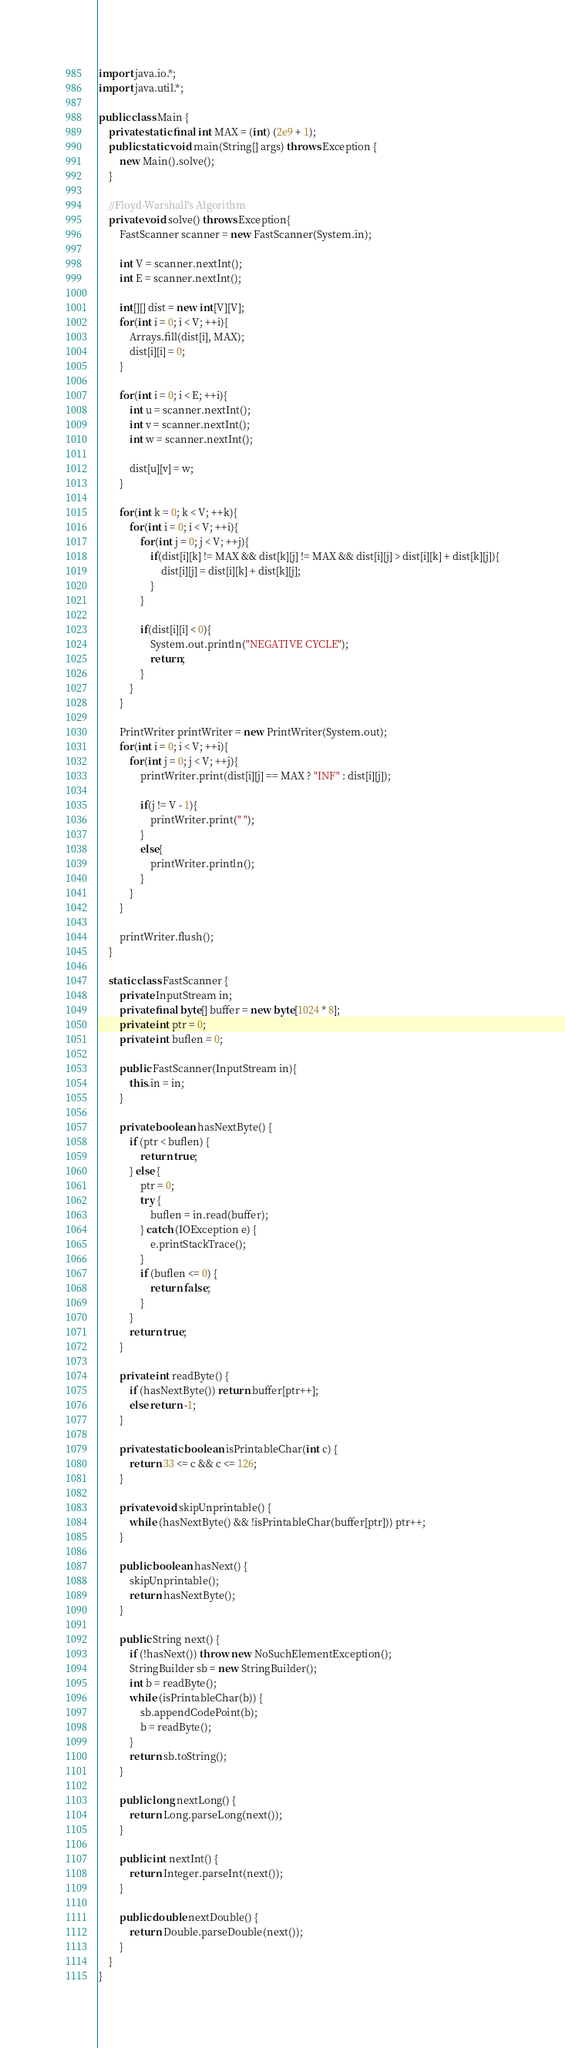<code> <loc_0><loc_0><loc_500><loc_500><_Java_>import java.io.*;
import java.util.*;

public class Main {
    private static final int MAX = (int) (2e9 + 1);
    public static void main(String[] args) throws Exception {
        new Main().solve();
    }

    //Floyd-Warshall's Algorithm
    private void solve() throws Exception{
        FastScanner scanner = new FastScanner(System.in);

        int V = scanner.nextInt();
        int E = scanner.nextInt();

        int[][] dist = new int[V][V];
        for(int i = 0; i < V; ++i){
            Arrays.fill(dist[i], MAX);
            dist[i][i] = 0;
        }

        for(int i = 0; i < E; ++i){
            int u = scanner.nextInt();
            int v = scanner.nextInt();
            int w = scanner.nextInt();

            dist[u][v] = w;
        }

        for(int k = 0; k < V; ++k){
            for(int i = 0; i < V; ++i){
                for(int j = 0; j < V; ++j){
                    if(dist[i][k] != MAX && dist[k][j] != MAX && dist[i][j] > dist[i][k] + dist[k][j]){
                        dist[i][j] = dist[i][k] + dist[k][j];
                    }
                }

                if(dist[i][i] < 0){
                    System.out.println("NEGATIVE CYCLE");
                    return;
                }
            }
        }

        PrintWriter printWriter = new PrintWriter(System.out);
        for(int i = 0; i < V; ++i){
            for(int j = 0; j < V; ++j){
                printWriter.print(dist[i][j] == MAX ? "INF" : dist[i][j]);

                if(j != V - 1){
                    printWriter.print(" ");
                }
                else{
                    printWriter.println();
                }
            }
        }

        printWriter.flush();
    }

    static class FastScanner {
        private InputStream in;
        private final byte[] buffer = new byte[1024 * 8];
        private int ptr = 0;
        private int buflen = 0;

        public FastScanner(InputStream in){
            this.in = in;
        }

        private boolean hasNextByte() {
            if (ptr < buflen) {
                return true;
            } else {
                ptr = 0;
                try {
                    buflen = in.read(buffer);
                } catch (IOException e) {
                    e.printStackTrace();
                }
                if (buflen <= 0) {
                    return false;
                }
            }
            return true;
        }

        private int readByte() {
            if (hasNextByte()) return buffer[ptr++];
            else return -1;
        }

        private static boolean isPrintableChar(int c) {
            return 33 <= c && c <= 126;
        }

        private void skipUnprintable() {
            while (hasNextByte() && !isPrintableChar(buffer[ptr])) ptr++;
        }

        public boolean hasNext() {
            skipUnprintable();
            return hasNextByte();
        }

        public String next() {
            if (!hasNext()) throw new NoSuchElementException();
            StringBuilder sb = new StringBuilder();
            int b = readByte();
            while (isPrintableChar(b)) {
                sb.appendCodePoint(b);
                b = readByte();
            }
            return sb.toString();
        }

        public long nextLong() {
            return Long.parseLong(next());
        }

        public int nextInt() {
            return Integer.parseInt(next());
        }

        public double nextDouble() {
            return Double.parseDouble(next());
        }
    }
}</code> 